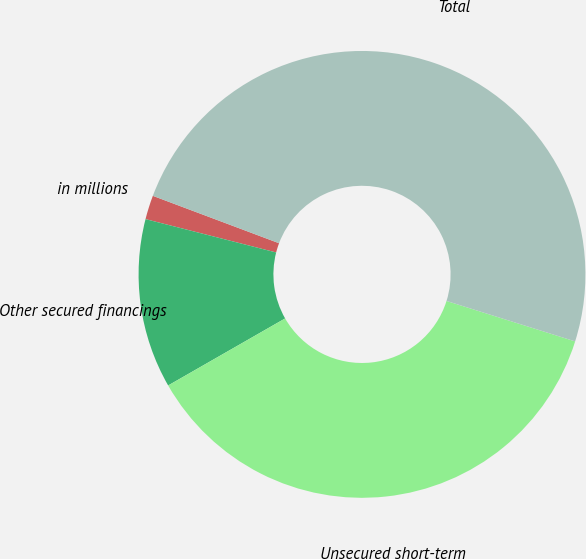Convert chart. <chart><loc_0><loc_0><loc_500><loc_500><pie_chart><fcel>in millions<fcel>Other secured financings<fcel>Unsecured short-term<fcel>Total<nl><fcel>1.74%<fcel>12.26%<fcel>36.87%<fcel>49.13%<nl></chart> 